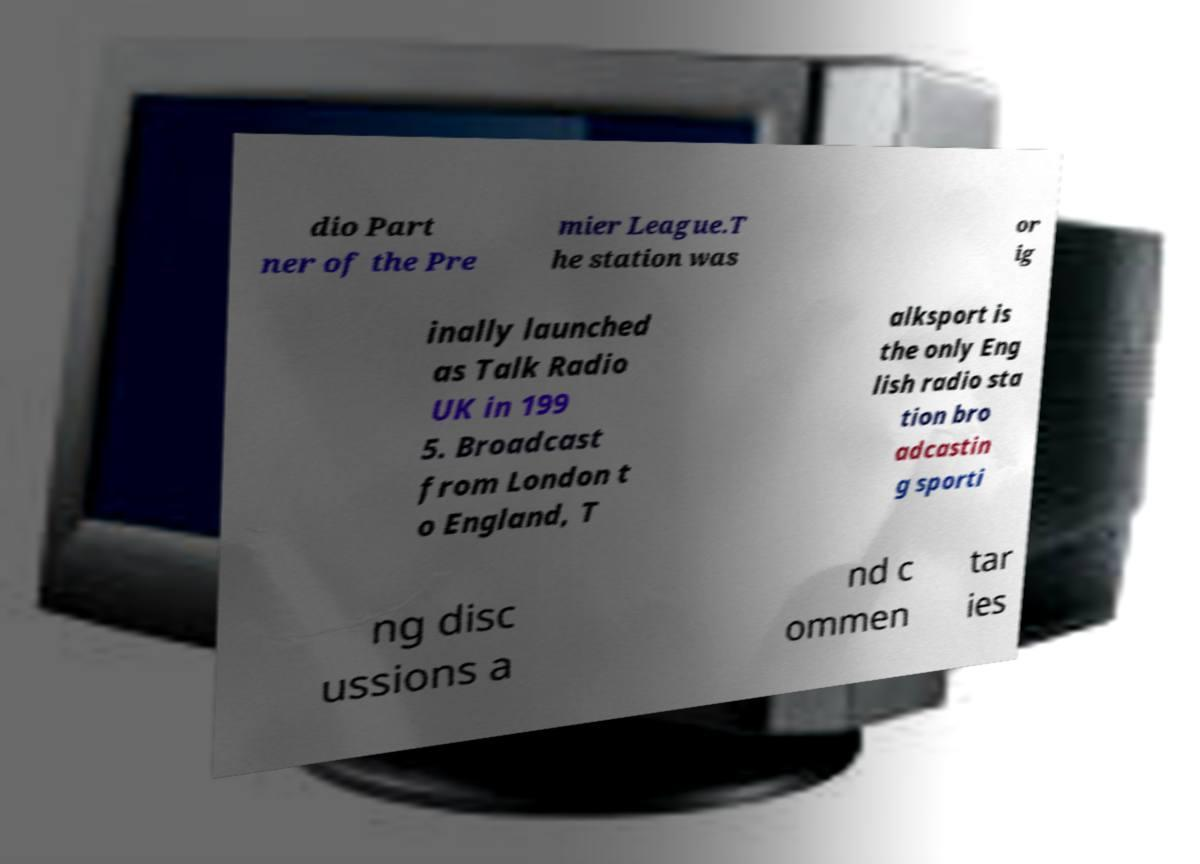Please read and relay the text visible in this image. What does it say? dio Part ner of the Pre mier League.T he station was or ig inally launched as Talk Radio UK in 199 5. Broadcast from London t o England, T alksport is the only Eng lish radio sta tion bro adcastin g sporti ng disc ussions a nd c ommen tar ies 